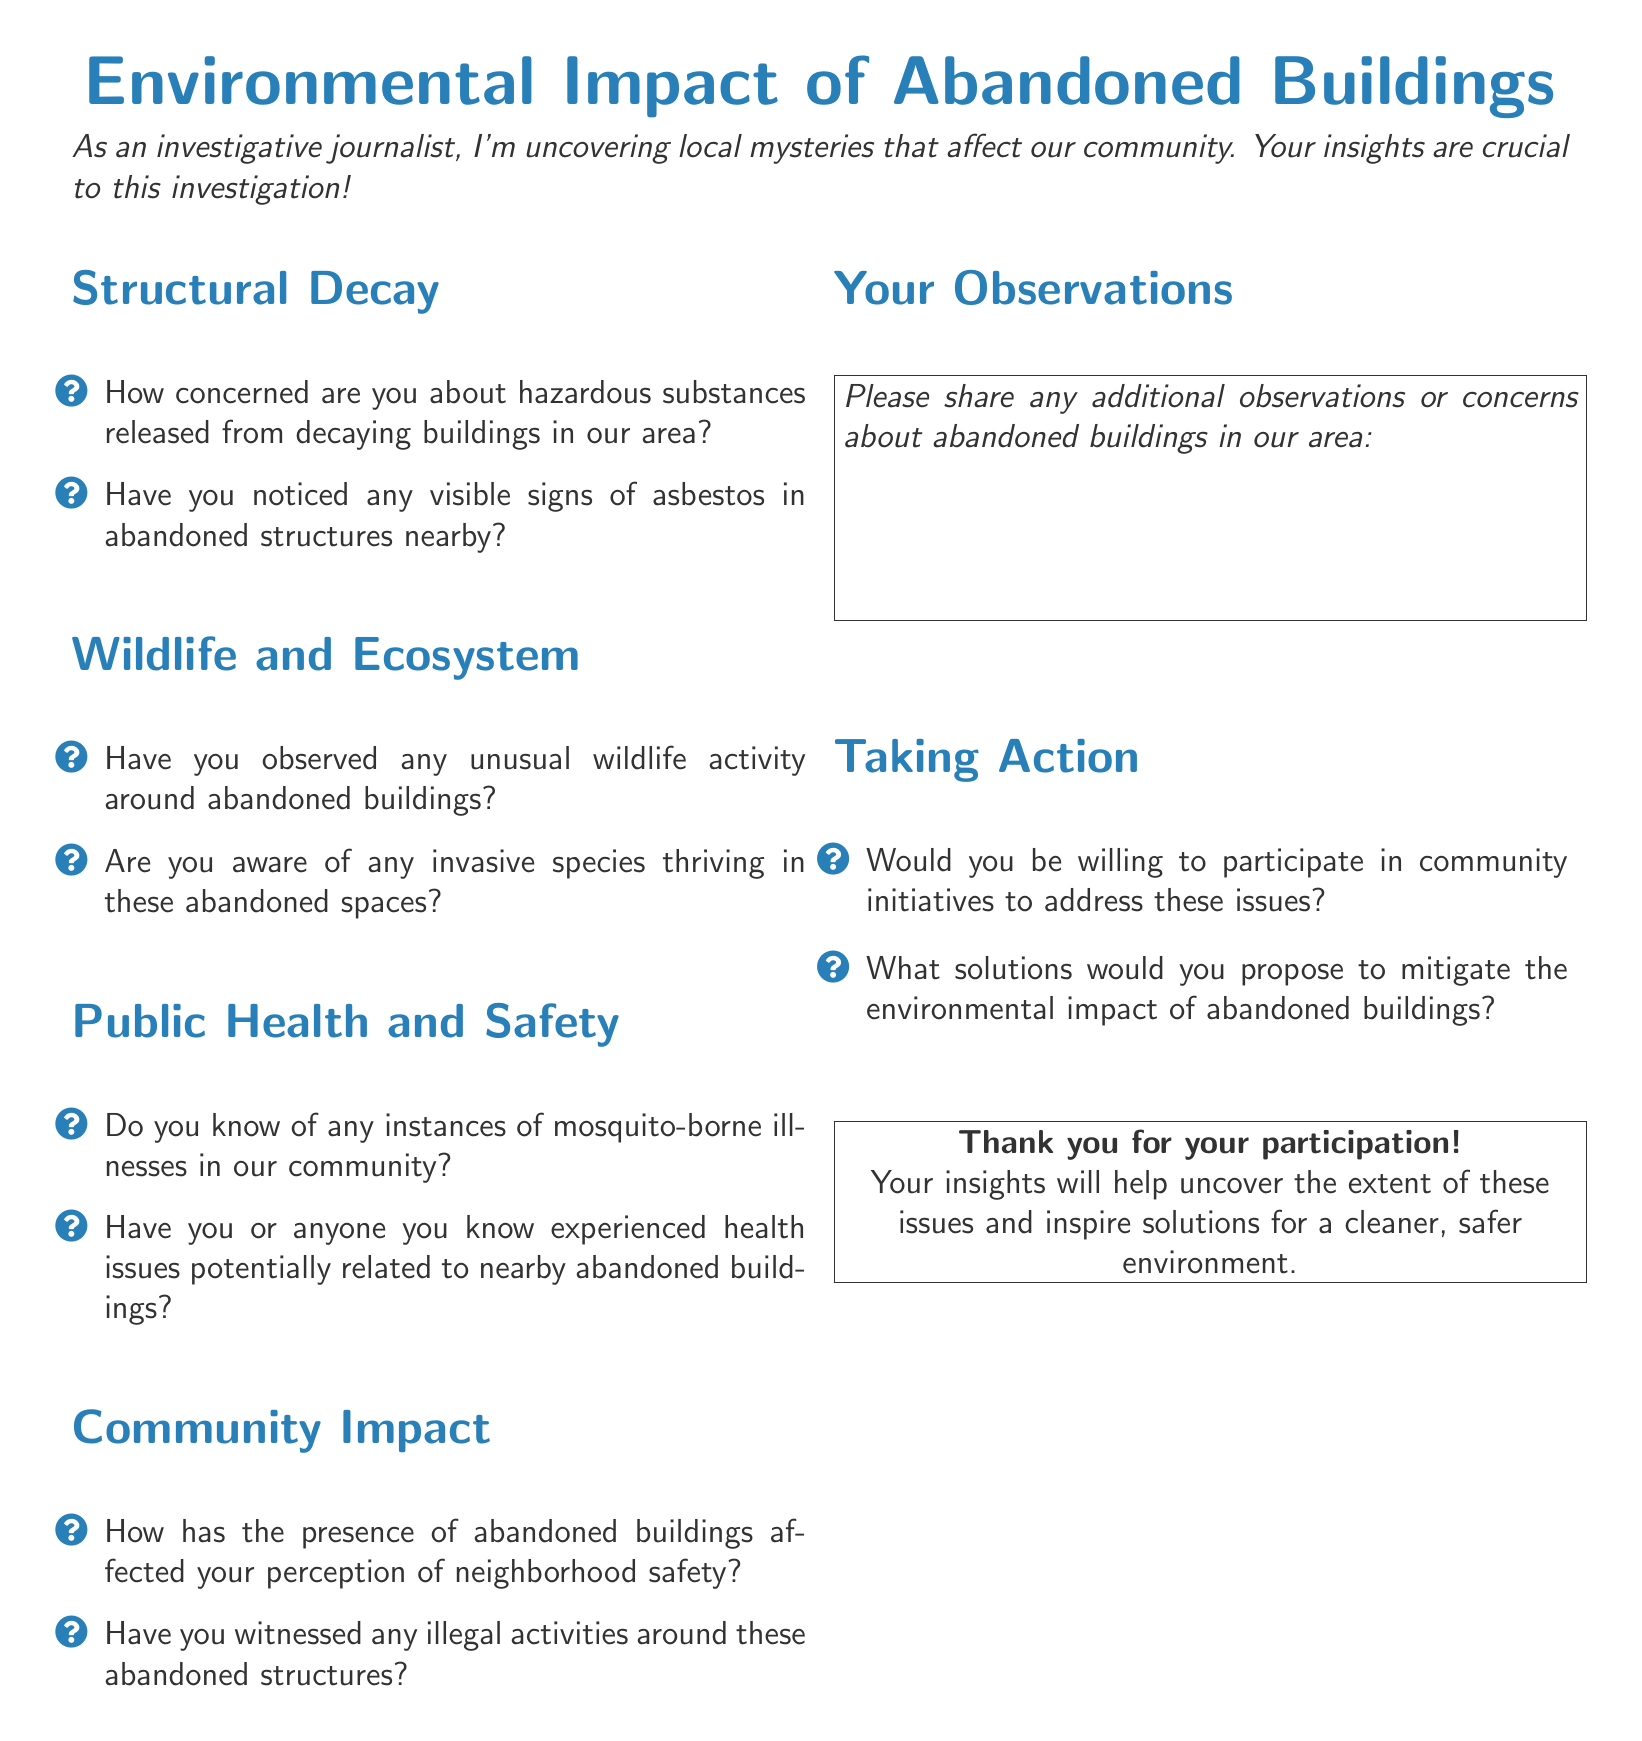What is the title of the document? The title is presented at the top of the document, clearly stating the focus of the questionnaire.
Answer: Environmental Impact of Abandoned Buildings How many sections are there in the document? The document includes four main sections listed before the questions start.
Answer: Four What color is used for the section titles? The color used for section titles is specified in the document as a particular shade of blue.
Answer: Mystery blue Which wildlife issue is mentioned in the document's wildlife section? The wildlife section includes questions related to unusual wildlife activity around abandoned buildings, highlighting environmental concerns.
Answer: Unusual wildlife activity What type of health issues does the public health section inquire about? This section addresses instances of health issues potentially related to the nearby abandoned buildings, indicating public health concerns.
Answer: Health issues Are there any community initiatives suggested in the document? The document asks participants if they would be willing to participate in initiatives, indicating a proactive approach to addressing the issues.
Answer: Yes What is requested in the "Your Observations" section? This section encourages participants to share additional insights related to abandoned buildings in their area, focusing on personal observations.
Answer: Observations or concerns What is the color scheme used for the text in the document? The text primarily uses a dark gray color, with specific elements highlighted in mystery blue throughout the document.
Answer: Dark gray and mystery blue What is the purpose of the questionnaire? The purpose is to uncover local mysteries and gather insights on the environmental impact of abandoned buildings from the community.
Answer: Investigative research 